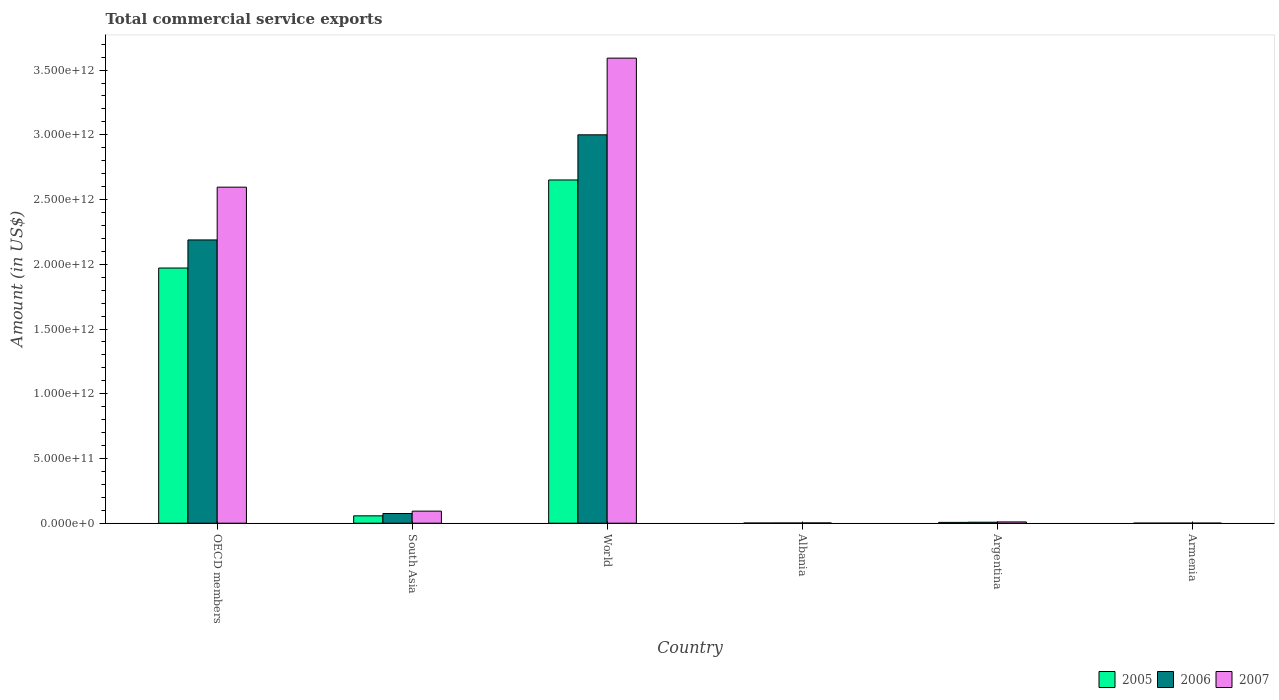How many groups of bars are there?
Provide a short and direct response. 6. Are the number of bars on each tick of the X-axis equal?
Offer a very short reply. Yes. How many bars are there on the 1st tick from the left?
Provide a succinct answer. 3. In how many cases, is the number of bars for a given country not equal to the number of legend labels?
Provide a succinct answer. 0. What is the total commercial service exports in 2005 in World?
Give a very brief answer. 2.65e+12. Across all countries, what is the maximum total commercial service exports in 2007?
Your answer should be compact. 3.59e+12. Across all countries, what is the minimum total commercial service exports in 2007?
Keep it short and to the point. 5.82e+08. In which country was the total commercial service exports in 2006 maximum?
Give a very brief answer. World. In which country was the total commercial service exports in 2007 minimum?
Give a very brief answer. Armenia. What is the total total commercial service exports in 2005 in the graph?
Your response must be concise. 4.69e+12. What is the difference between the total commercial service exports in 2006 in Albania and that in Armenia?
Ensure brevity in your answer.  1.14e+09. What is the difference between the total commercial service exports in 2005 in Armenia and the total commercial service exports in 2006 in Albania?
Give a very brief answer. -1.20e+09. What is the average total commercial service exports in 2006 per country?
Your answer should be compact. 8.79e+11. What is the difference between the total commercial service exports of/in 2005 and total commercial service exports of/in 2007 in South Asia?
Give a very brief answer. -3.64e+1. What is the ratio of the total commercial service exports in 2006 in Armenia to that in OECD members?
Your answer should be very brief. 0. Is the difference between the total commercial service exports in 2005 in South Asia and World greater than the difference between the total commercial service exports in 2007 in South Asia and World?
Give a very brief answer. Yes. What is the difference between the highest and the second highest total commercial service exports in 2006?
Provide a short and direct response. 8.12e+11. What is the difference between the highest and the lowest total commercial service exports in 2006?
Make the answer very short. 3.00e+12. Is the sum of the total commercial service exports in 2007 in Armenia and World greater than the maximum total commercial service exports in 2005 across all countries?
Offer a very short reply. Yes. How many bars are there?
Give a very brief answer. 18. Are all the bars in the graph horizontal?
Provide a short and direct response. No. What is the difference between two consecutive major ticks on the Y-axis?
Offer a terse response. 5.00e+11. Are the values on the major ticks of Y-axis written in scientific E-notation?
Offer a very short reply. Yes. How many legend labels are there?
Offer a terse response. 3. How are the legend labels stacked?
Provide a short and direct response. Horizontal. What is the title of the graph?
Provide a succinct answer. Total commercial service exports. Does "1964" appear as one of the legend labels in the graph?
Offer a very short reply. No. What is the label or title of the X-axis?
Offer a very short reply. Country. What is the Amount (in US$) in 2005 in OECD members?
Your answer should be very brief. 1.97e+12. What is the Amount (in US$) of 2006 in OECD members?
Offer a very short reply. 2.19e+12. What is the Amount (in US$) of 2007 in OECD members?
Offer a terse response. 2.60e+12. What is the Amount (in US$) in 2005 in South Asia?
Make the answer very short. 5.69e+1. What is the Amount (in US$) of 2006 in South Asia?
Your answer should be compact. 7.48e+1. What is the Amount (in US$) of 2007 in South Asia?
Provide a short and direct response. 9.33e+1. What is the Amount (in US$) in 2005 in World?
Your response must be concise. 2.65e+12. What is the Amount (in US$) of 2006 in World?
Provide a succinct answer. 3.00e+12. What is the Amount (in US$) of 2007 in World?
Your response must be concise. 3.59e+12. What is the Amount (in US$) of 2005 in Albania?
Your answer should be compact. 1.26e+09. What is the Amount (in US$) of 2006 in Albania?
Offer a terse response. 1.62e+09. What is the Amount (in US$) in 2007 in Albania?
Your response must be concise. 2.08e+09. What is the Amount (in US$) in 2005 in Argentina?
Your response must be concise. 6.34e+09. What is the Amount (in US$) of 2006 in Argentina?
Ensure brevity in your answer.  7.71e+09. What is the Amount (in US$) of 2007 in Argentina?
Give a very brief answer. 1.00e+1. What is the Amount (in US$) in 2005 in Armenia?
Your response must be concise. 4.22e+08. What is the Amount (in US$) in 2006 in Armenia?
Offer a terse response. 4.87e+08. What is the Amount (in US$) in 2007 in Armenia?
Keep it short and to the point. 5.82e+08. Across all countries, what is the maximum Amount (in US$) in 2005?
Your response must be concise. 2.65e+12. Across all countries, what is the maximum Amount (in US$) of 2006?
Offer a very short reply. 3.00e+12. Across all countries, what is the maximum Amount (in US$) of 2007?
Your answer should be compact. 3.59e+12. Across all countries, what is the minimum Amount (in US$) in 2005?
Make the answer very short. 4.22e+08. Across all countries, what is the minimum Amount (in US$) of 2006?
Your response must be concise. 4.87e+08. Across all countries, what is the minimum Amount (in US$) in 2007?
Make the answer very short. 5.82e+08. What is the total Amount (in US$) in 2005 in the graph?
Offer a very short reply. 4.69e+12. What is the total Amount (in US$) of 2006 in the graph?
Give a very brief answer. 5.27e+12. What is the total Amount (in US$) of 2007 in the graph?
Your answer should be compact. 6.29e+12. What is the difference between the Amount (in US$) of 2005 in OECD members and that in South Asia?
Keep it short and to the point. 1.91e+12. What is the difference between the Amount (in US$) in 2006 in OECD members and that in South Asia?
Give a very brief answer. 2.11e+12. What is the difference between the Amount (in US$) of 2007 in OECD members and that in South Asia?
Make the answer very short. 2.50e+12. What is the difference between the Amount (in US$) in 2005 in OECD members and that in World?
Offer a very short reply. -6.80e+11. What is the difference between the Amount (in US$) of 2006 in OECD members and that in World?
Make the answer very short. -8.12e+11. What is the difference between the Amount (in US$) in 2007 in OECD members and that in World?
Offer a terse response. -9.97e+11. What is the difference between the Amount (in US$) in 2005 in OECD members and that in Albania?
Give a very brief answer. 1.97e+12. What is the difference between the Amount (in US$) of 2006 in OECD members and that in Albania?
Make the answer very short. 2.19e+12. What is the difference between the Amount (in US$) in 2007 in OECD members and that in Albania?
Give a very brief answer. 2.59e+12. What is the difference between the Amount (in US$) of 2005 in OECD members and that in Argentina?
Provide a succinct answer. 1.96e+12. What is the difference between the Amount (in US$) of 2006 in OECD members and that in Argentina?
Offer a terse response. 2.18e+12. What is the difference between the Amount (in US$) in 2007 in OECD members and that in Argentina?
Provide a succinct answer. 2.59e+12. What is the difference between the Amount (in US$) of 2005 in OECD members and that in Armenia?
Your answer should be compact. 1.97e+12. What is the difference between the Amount (in US$) of 2006 in OECD members and that in Armenia?
Your response must be concise. 2.19e+12. What is the difference between the Amount (in US$) of 2007 in OECD members and that in Armenia?
Offer a terse response. 2.60e+12. What is the difference between the Amount (in US$) in 2005 in South Asia and that in World?
Offer a very short reply. -2.59e+12. What is the difference between the Amount (in US$) of 2006 in South Asia and that in World?
Your answer should be compact. -2.93e+12. What is the difference between the Amount (in US$) of 2007 in South Asia and that in World?
Provide a short and direct response. -3.50e+12. What is the difference between the Amount (in US$) of 2005 in South Asia and that in Albania?
Give a very brief answer. 5.57e+1. What is the difference between the Amount (in US$) of 2006 in South Asia and that in Albania?
Provide a succinct answer. 7.32e+1. What is the difference between the Amount (in US$) in 2007 in South Asia and that in Albania?
Your answer should be very brief. 9.12e+1. What is the difference between the Amount (in US$) in 2005 in South Asia and that in Argentina?
Make the answer very short. 5.06e+1. What is the difference between the Amount (in US$) of 2006 in South Asia and that in Argentina?
Offer a terse response. 6.71e+1. What is the difference between the Amount (in US$) in 2007 in South Asia and that in Argentina?
Provide a succinct answer. 8.33e+1. What is the difference between the Amount (in US$) in 2005 in South Asia and that in Armenia?
Provide a succinct answer. 5.65e+1. What is the difference between the Amount (in US$) of 2006 in South Asia and that in Armenia?
Your answer should be very brief. 7.43e+1. What is the difference between the Amount (in US$) of 2007 in South Asia and that in Armenia?
Provide a short and direct response. 9.27e+1. What is the difference between the Amount (in US$) in 2005 in World and that in Albania?
Offer a terse response. 2.65e+12. What is the difference between the Amount (in US$) in 2006 in World and that in Albania?
Provide a succinct answer. 3.00e+12. What is the difference between the Amount (in US$) of 2007 in World and that in Albania?
Make the answer very short. 3.59e+12. What is the difference between the Amount (in US$) of 2005 in World and that in Argentina?
Offer a terse response. 2.64e+12. What is the difference between the Amount (in US$) in 2006 in World and that in Argentina?
Make the answer very short. 2.99e+12. What is the difference between the Amount (in US$) in 2007 in World and that in Argentina?
Your answer should be compact. 3.58e+12. What is the difference between the Amount (in US$) of 2005 in World and that in Armenia?
Your answer should be very brief. 2.65e+12. What is the difference between the Amount (in US$) in 2006 in World and that in Armenia?
Give a very brief answer. 3.00e+12. What is the difference between the Amount (in US$) of 2007 in World and that in Armenia?
Offer a terse response. 3.59e+12. What is the difference between the Amount (in US$) of 2005 in Albania and that in Argentina?
Provide a short and direct response. -5.09e+09. What is the difference between the Amount (in US$) in 2006 in Albania and that in Argentina?
Offer a terse response. -6.09e+09. What is the difference between the Amount (in US$) in 2007 in Albania and that in Argentina?
Offer a very short reply. -7.92e+09. What is the difference between the Amount (in US$) in 2005 in Albania and that in Armenia?
Make the answer very short. 8.34e+08. What is the difference between the Amount (in US$) of 2006 in Albania and that in Armenia?
Your answer should be compact. 1.14e+09. What is the difference between the Amount (in US$) of 2007 in Albania and that in Armenia?
Make the answer very short. 1.50e+09. What is the difference between the Amount (in US$) in 2005 in Argentina and that in Armenia?
Provide a short and direct response. 5.92e+09. What is the difference between the Amount (in US$) in 2006 in Argentina and that in Armenia?
Offer a very short reply. 7.23e+09. What is the difference between the Amount (in US$) in 2007 in Argentina and that in Armenia?
Your answer should be compact. 9.42e+09. What is the difference between the Amount (in US$) of 2005 in OECD members and the Amount (in US$) of 2006 in South Asia?
Your response must be concise. 1.90e+12. What is the difference between the Amount (in US$) of 2005 in OECD members and the Amount (in US$) of 2007 in South Asia?
Make the answer very short. 1.88e+12. What is the difference between the Amount (in US$) of 2006 in OECD members and the Amount (in US$) of 2007 in South Asia?
Give a very brief answer. 2.09e+12. What is the difference between the Amount (in US$) of 2005 in OECD members and the Amount (in US$) of 2006 in World?
Your answer should be compact. -1.03e+12. What is the difference between the Amount (in US$) of 2005 in OECD members and the Amount (in US$) of 2007 in World?
Give a very brief answer. -1.62e+12. What is the difference between the Amount (in US$) of 2006 in OECD members and the Amount (in US$) of 2007 in World?
Provide a succinct answer. -1.40e+12. What is the difference between the Amount (in US$) of 2005 in OECD members and the Amount (in US$) of 2006 in Albania?
Offer a terse response. 1.97e+12. What is the difference between the Amount (in US$) of 2005 in OECD members and the Amount (in US$) of 2007 in Albania?
Keep it short and to the point. 1.97e+12. What is the difference between the Amount (in US$) of 2006 in OECD members and the Amount (in US$) of 2007 in Albania?
Offer a very short reply. 2.19e+12. What is the difference between the Amount (in US$) in 2005 in OECD members and the Amount (in US$) in 2006 in Argentina?
Ensure brevity in your answer.  1.96e+12. What is the difference between the Amount (in US$) of 2005 in OECD members and the Amount (in US$) of 2007 in Argentina?
Your answer should be very brief. 1.96e+12. What is the difference between the Amount (in US$) in 2006 in OECD members and the Amount (in US$) in 2007 in Argentina?
Ensure brevity in your answer.  2.18e+12. What is the difference between the Amount (in US$) of 2005 in OECD members and the Amount (in US$) of 2006 in Armenia?
Give a very brief answer. 1.97e+12. What is the difference between the Amount (in US$) in 2005 in OECD members and the Amount (in US$) in 2007 in Armenia?
Provide a succinct answer. 1.97e+12. What is the difference between the Amount (in US$) in 2006 in OECD members and the Amount (in US$) in 2007 in Armenia?
Your response must be concise. 2.19e+12. What is the difference between the Amount (in US$) of 2005 in South Asia and the Amount (in US$) of 2006 in World?
Offer a very short reply. -2.94e+12. What is the difference between the Amount (in US$) of 2005 in South Asia and the Amount (in US$) of 2007 in World?
Provide a succinct answer. -3.54e+12. What is the difference between the Amount (in US$) of 2006 in South Asia and the Amount (in US$) of 2007 in World?
Offer a very short reply. -3.52e+12. What is the difference between the Amount (in US$) of 2005 in South Asia and the Amount (in US$) of 2006 in Albania?
Give a very brief answer. 5.53e+1. What is the difference between the Amount (in US$) in 2005 in South Asia and the Amount (in US$) in 2007 in Albania?
Keep it short and to the point. 5.48e+1. What is the difference between the Amount (in US$) in 2006 in South Asia and the Amount (in US$) in 2007 in Albania?
Ensure brevity in your answer.  7.27e+1. What is the difference between the Amount (in US$) of 2005 in South Asia and the Amount (in US$) of 2006 in Argentina?
Your answer should be compact. 4.92e+1. What is the difference between the Amount (in US$) in 2005 in South Asia and the Amount (in US$) in 2007 in Argentina?
Your answer should be compact. 4.69e+1. What is the difference between the Amount (in US$) of 2006 in South Asia and the Amount (in US$) of 2007 in Argentina?
Provide a succinct answer. 6.48e+1. What is the difference between the Amount (in US$) in 2005 in South Asia and the Amount (in US$) in 2006 in Armenia?
Give a very brief answer. 5.64e+1. What is the difference between the Amount (in US$) of 2005 in South Asia and the Amount (in US$) of 2007 in Armenia?
Provide a short and direct response. 5.63e+1. What is the difference between the Amount (in US$) of 2006 in South Asia and the Amount (in US$) of 2007 in Armenia?
Provide a short and direct response. 7.42e+1. What is the difference between the Amount (in US$) of 2005 in World and the Amount (in US$) of 2006 in Albania?
Your answer should be compact. 2.65e+12. What is the difference between the Amount (in US$) in 2005 in World and the Amount (in US$) in 2007 in Albania?
Your response must be concise. 2.65e+12. What is the difference between the Amount (in US$) in 2006 in World and the Amount (in US$) in 2007 in Albania?
Your answer should be very brief. 3.00e+12. What is the difference between the Amount (in US$) in 2005 in World and the Amount (in US$) in 2006 in Argentina?
Keep it short and to the point. 2.64e+12. What is the difference between the Amount (in US$) in 2005 in World and the Amount (in US$) in 2007 in Argentina?
Make the answer very short. 2.64e+12. What is the difference between the Amount (in US$) in 2006 in World and the Amount (in US$) in 2007 in Argentina?
Provide a succinct answer. 2.99e+12. What is the difference between the Amount (in US$) of 2005 in World and the Amount (in US$) of 2006 in Armenia?
Your answer should be very brief. 2.65e+12. What is the difference between the Amount (in US$) of 2005 in World and the Amount (in US$) of 2007 in Armenia?
Your answer should be very brief. 2.65e+12. What is the difference between the Amount (in US$) in 2006 in World and the Amount (in US$) in 2007 in Armenia?
Offer a terse response. 3.00e+12. What is the difference between the Amount (in US$) of 2005 in Albania and the Amount (in US$) of 2006 in Argentina?
Your response must be concise. -6.46e+09. What is the difference between the Amount (in US$) of 2005 in Albania and the Amount (in US$) of 2007 in Argentina?
Your answer should be compact. -8.75e+09. What is the difference between the Amount (in US$) of 2006 in Albania and the Amount (in US$) of 2007 in Argentina?
Provide a short and direct response. -8.38e+09. What is the difference between the Amount (in US$) in 2005 in Albania and the Amount (in US$) in 2006 in Armenia?
Provide a succinct answer. 7.69e+08. What is the difference between the Amount (in US$) of 2005 in Albania and the Amount (in US$) of 2007 in Armenia?
Offer a very short reply. 6.75e+08. What is the difference between the Amount (in US$) of 2006 in Albania and the Amount (in US$) of 2007 in Armenia?
Provide a succinct answer. 1.04e+09. What is the difference between the Amount (in US$) in 2005 in Argentina and the Amount (in US$) in 2006 in Armenia?
Your response must be concise. 5.86e+09. What is the difference between the Amount (in US$) of 2005 in Argentina and the Amount (in US$) of 2007 in Armenia?
Your answer should be compact. 5.76e+09. What is the difference between the Amount (in US$) of 2006 in Argentina and the Amount (in US$) of 2007 in Armenia?
Provide a short and direct response. 7.13e+09. What is the average Amount (in US$) in 2005 per country?
Your response must be concise. 7.81e+11. What is the average Amount (in US$) of 2006 per country?
Offer a terse response. 8.79e+11. What is the average Amount (in US$) of 2007 per country?
Give a very brief answer. 1.05e+12. What is the difference between the Amount (in US$) of 2005 and Amount (in US$) of 2006 in OECD members?
Your response must be concise. -2.17e+11. What is the difference between the Amount (in US$) in 2005 and Amount (in US$) in 2007 in OECD members?
Provide a short and direct response. -6.25e+11. What is the difference between the Amount (in US$) of 2006 and Amount (in US$) of 2007 in OECD members?
Give a very brief answer. -4.08e+11. What is the difference between the Amount (in US$) in 2005 and Amount (in US$) in 2006 in South Asia?
Provide a succinct answer. -1.79e+1. What is the difference between the Amount (in US$) in 2005 and Amount (in US$) in 2007 in South Asia?
Keep it short and to the point. -3.64e+1. What is the difference between the Amount (in US$) in 2006 and Amount (in US$) in 2007 in South Asia?
Your response must be concise. -1.85e+1. What is the difference between the Amount (in US$) of 2005 and Amount (in US$) of 2006 in World?
Your answer should be compact. -3.49e+11. What is the difference between the Amount (in US$) in 2005 and Amount (in US$) in 2007 in World?
Ensure brevity in your answer.  -9.41e+11. What is the difference between the Amount (in US$) of 2006 and Amount (in US$) of 2007 in World?
Provide a succinct answer. -5.92e+11. What is the difference between the Amount (in US$) of 2005 and Amount (in US$) of 2006 in Albania?
Ensure brevity in your answer.  -3.67e+08. What is the difference between the Amount (in US$) in 2005 and Amount (in US$) in 2007 in Albania?
Your answer should be very brief. -8.26e+08. What is the difference between the Amount (in US$) of 2006 and Amount (in US$) of 2007 in Albania?
Your answer should be compact. -4.59e+08. What is the difference between the Amount (in US$) in 2005 and Amount (in US$) in 2006 in Argentina?
Provide a succinct answer. -1.37e+09. What is the difference between the Amount (in US$) in 2005 and Amount (in US$) in 2007 in Argentina?
Offer a very short reply. -3.66e+09. What is the difference between the Amount (in US$) in 2006 and Amount (in US$) in 2007 in Argentina?
Your answer should be compact. -2.29e+09. What is the difference between the Amount (in US$) of 2005 and Amount (in US$) of 2006 in Armenia?
Provide a short and direct response. -6.57e+07. What is the difference between the Amount (in US$) in 2005 and Amount (in US$) in 2007 in Armenia?
Ensure brevity in your answer.  -1.60e+08. What is the difference between the Amount (in US$) in 2006 and Amount (in US$) in 2007 in Armenia?
Give a very brief answer. -9.43e+07. What is the ratio of the Amount (in US$) of 2005 in OECD members to that in South Asia?
Make the answer very short. 34.63. What is the ratio of the Amount (in US$) in 2006 in OECD members to that in South Asia?
Keep it short and to the point. 29.24. What is the ratio of the Amount (in US$) of 2007 in OECD members to that in South Asia?
Make the answer very short. 27.82. What is the ratio of the Amount (in US$) in 2005 in OECD members to that in World?
Provide a short and direct response. 0.74. What is the ratio of the Amount (in US$) in 2006 in OECD members to that in World?
Your answer should be compact. 0.73. What is the ratio of the Amount (in US$) in 2007 in OECD members to that in World?
Your response must be concise. 0.72. What is the ratio of the Amount (in US$) in 2005 in OECD members to that in Albania?
Your response must be concise. 1569.01. What is the ratio of the Amount (in US$) of 2006 in OECD members to that in Albania?
Make the answer very short. 1348.12. What is the ratio of the Amount (in US$) in 2007 in OECD members to that in Albania?
Keep it short and to the point. 1246.38. What is the ratio of the Amount (in US$) in 2005 in OECD members to that in Argentina?
Provide a short and direct response. 310.75. What is the ratio of the Amount (in US$) of 2006 in OECD members to that in Argentina?
Your response must be concise. 283.67. What is the ratio of the Amount (in US$) of 2007 in OECD members to that in Argentina?
Ensure brevity in your answer.  259.39. What is the ratio of the Amount (in US$) of 2005 in OECD members to that in Armenia?
Your answer should be very brief. 4672.94. What is the ratio of the Amount (in US$) of 2006 in OECD members to that in Armenia?
Give a very brief answer. 4488.64. What is the ratio of the Amount (in US$) in 2007 in OECD members to that in Armenia?
Give a very brief answer. 4461.79. What is the ratio of the Amount (in US$) of 2005 in South Asia to that in World?
Make the answer very short. 0.02. What is the ratio of the Amount (in US$) in 2006 in South Asia to that in World?
Offer a terse response. 0.02. What is the ratio of the Amount (in US$) of 2007 in South Asia to that in World?
Provide a succinct answer. 0.03. What is the ratio of the Amount (in US$) of 2005 in South Asia to that in Albania?
Offer a very short reply. 45.3. What is the ratio of the Amount (in US$) of 2006 in South Asia to that in Albania?
Provide a succinct answer. 46.1. What is the ratio of the Amount (in US$) of 2007 in South Asia to that in Albania?
Give a very brief answer. 44.79. What is the ratio of the Amount (in US$) in 2005 in South Asia to that in Argentina?
Provide a short and direct response. 8.97. What is the ratio of the Amount (in US$) in 2006 in South Asia to that in Argentina?
Your answer should be very brief. 9.7. What is the ratio of the Amount (in US$) in 2007 in South Asia to that in Argentina?
Offer a very short reply. 9.32. What is the ratio of the Amount (in US$) in 2005 in South Asia to that in Armenia?
Ensure brevity in your answer.  134.93. What is the ratio of the Amount (in US$) in 2006 in South Asia to that in Armenia?
Your response must be concise. 153.51. What is the ratio of the Amount (in US$) in 2007 in South Asia to that in Armenia?
Your answer should be compact. 160.36. What is the ratio of the Amount (in US$) in 2005 in World to that in Albania?
Give a very brief answer. 2110.43. What is the ratio of the Amount (in US$) of 2006 in World to that in Albania?
Offer a very short reply. 1848.32. What is the ratio of the Amount (in US$) of 2007 in World to that in Albania?
Your response must be concise. 1724.98. What is the ratio of the Amount (in US$) of 2005 in World to that in Argentina?
Your response must be concise. 417.99. What is the ratio of the Amount (in US$) in 2006 in World to that in Argentina?
Keep it short and to the point. 388.92. What is the ratio of the Amount (in US$) of 2007 in World to that in Argentina?
Your answer should be very brief. 359. What is the ratio of the Amount (in US$) in 2005 in World to that in Armenia?
Offer a terse response. 6285.44. What is the ratio of the Amount (in US$) of 2006 in World to that in Armenia?
Make the answer very short. 6154.1. What is the ratio of the Amount (in US$) of 2007 in World to that in Armenia?
Provide a succinct answer. 6175.11. What is the ratio of the Amount (in US$) in 2005 in Albania to that in Argentina?
Give a very brief answer. 0.2. What is the ratio of the Amount (in US$) in 2006 in Albania to that in Argentina?
Provide a succinct answer. 0.21. What is the ratio of the Amount (in US$) of 2007 in Albania to that in Argentina?
Your answer should be compact. 0.21. What is the ratio of the Amount (in US$) in 2005 in Albania to that in Armenia?
Offer a very short reply. 2.98. What is the ratio of the Amount (in US$) of 2006 in Albania to that in Armenia?
Keep it short and to the point. 3.33. What is the ratio of the Amount (in US$) in 2007 in Albania to that in Armenia?
Your answer should be compact. 3.58. What is the ratio of the Amount (in US$) in 2005 in Argentina to that in Armenia?
Keep it short and to the point. 15.04. What is the ratio of the Amount (in US$) of 2006 in Argentina to that in Armenia?
Your response must be concise. 15.82. What is the ratio of the Amount (in US$) of 2007 in Argentina to that in Armenia?
Provide a succinct answer. 17.2. What is the difference between the highest and the second highest Amount (in US$) in 2005?
Offer a terse response. 6.80e+11. What is the difference between the highest and the second highest Amount (in US$) of 2006?
Your answer should be compact. 8.12e+11. What is the difference between the highest and the second highest Amount (in US$) in 2007?
Provide a succinct answer. 9.97e+11. What is the difference between the highest and the lowest Amount (in US$) of 2005?
Provide a short and direct response. 2.65e+12. What is the difference between the highest and the lowest Amount (in US$) in 2006?
Offer a very short reply. 3.00e+12. What is the difference between the highest and the lowest Amount (in US$) of 2007?
Ensure brevity in your answer.  3.59e+12. 